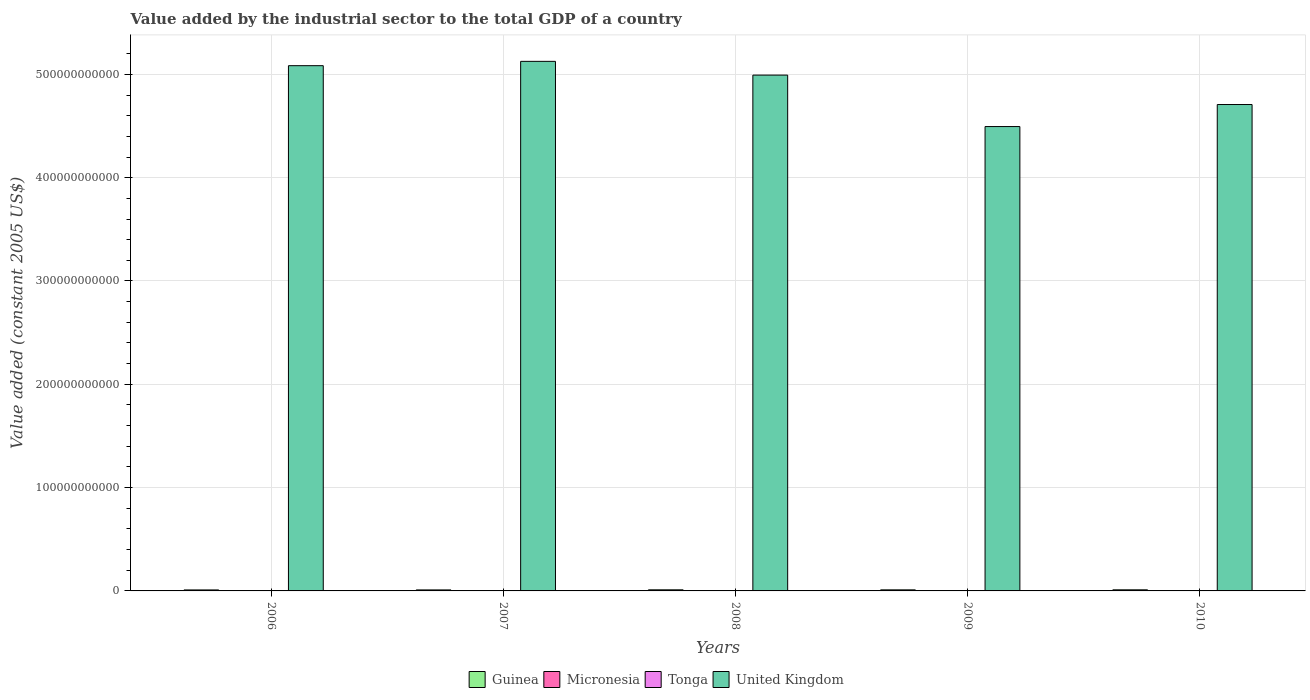How many groups of bars are there?
Your answer should be compact. 5. Are the number of bars per tick equal to the number of legend labels?
Make the answer very short. Yes. In how many cases, is the number of bars for a given year not equal to the number of legend labels?
Ensure brevity in your answer.  0. What is the value added by the industrial sector in Guinea in 2007?
Provide a short and direct response. 9.79e+08. Across all years, what is the maximum value added by the industrial sector in Guinea?
Make the answer very short. 1.07e+09. Across all years, what is the minimum value added by the industrial sector in United Kingdom?
Keep it short and to the point. 4.49e+11. What is the total value added by the industrial sector in Tonga in the graph?
Provide a short and direct response. 2.22e+08. What is the difference between the value added by the industrial sector in Micronesia in 2007 and that in 2008?
Give a very brief answer. -7.32e+05. What is the difference between the value added by the industrial sector in Micronesia in 2009 and the value added by the industrial sector in Tonga in 2006?
Make the answer very short. -2.85e+07. What is the average value added by the industrial sector in Micronesia per year?
Provide a short and direct response. 1.21e+07. In the year 2006, what is the difference between the value added by the industrial sector in United Kingdom and value added by the industrial sector in Tonga?
Offer a terse response. 5.08e+11. What is the ratio of the value added by the industrial sector in Micronesia in 2006 to that in 2008?
Offer a very short reply. 0.99. What is the difference between the highest and the second highest value added by the industrial sector in Tonga?
Ensure brevity in your answer.  5.36e+06. What is the difference between the highest and the lowest value added by the industrial sector in United Kingdom?
Provide a succinct answer. 6.31e+1. In how many years, is the value added by the industrial sector in United Kingdom greater than the average value added by the industrial sector in United Kingdom taken over all years?
Ensure brevity in your answer.  3. Is the sum of the value added by the industrial sector in Micronesia in 2006 and 2010 greater than the maximum value added by the industrial sector in Guinea across all years?
Give a very brief answer. No. What does the 3rd bar from the left in 2010 represents?
Offer a very short reply. Tonga. What does the 4th bar from the right in 2008 represents?
Give a very brief answer. Guinea. How many bars are there?
Offer a very short reply. 20. What is the difference between two consecutive major ticks on the Y-axis?
Your answer should be compact. 1.00e+11. Where does the legend appear in the graph?
Give a very brief answer. Bottom center. How many legend labels are there?
Your answer should be compact. 4. What is the title of the graph?
Provide a succinct answer. Value added by the industrial sector to the total GDP of a country. Does "New Caledonia" appear as one of the legend labels in the graph?
Your answer should be compact. No. What is the label or title of the X-axis?
Provide a succinct answer. Years. What is the label or title of the Y-axis?
Your answer should be very brief. Value added (constant 2005 US$). What is the Value added (constant 2005 US$) in Guinea in 2006?
Make the answer very short. 9.63e+08. What is the Value added (constant 2005 US$) of Micronesia in 2006?
Your answer should be compact. 1.03e+07. What is the Value added (constant 2005 US$) in Tonga in 2006?
Give a very brief answer. 4.26e+07. What is the Value added (constant 2005 US$) of United Kingdom in 2006?
Offer a very short reply. 5.08e+11. What is the Value added (constant 2005 US$) of Guinea in 2007?
Offer a terse response. 9.79e+08. What is the Value added (constant 2005 US$) of Micronesia in 2007?
Offer a terse response. 9.61e+06. What is the Value added (constant 2005 US$) of Tonga in 2007?
Ensure brevity in your answer.  4.06e+07. What is the Value added (constant 2005 US$) of United Kingdom in 2007?
Your answer should be very brief. 5.13e+11. What is the Value added (constant 2005 US$) of Guinea in 2008?
Your answer should be compact. 1.07e+09. What is the Value added (constant 2005 US$) of Micronesia in 2008?
Make the answer very short. 1.03e+07. What is the Value added (constant 2005 US$) in Tonga in 2008?
Your answer should be very brief. 4.08e+07. What is the Value added (constant 2005 US$) of United Kingdom in 2008?
Your answer should be compact. 4.99e+11. What is the Value added (constant 2005 US$) of Guinea in 2009?
Give a very brief answer. 1.04e+09. What is the Value added (constant 2005 US$) in Micronesia in 2009?
Give a very brief answer. 1.41e+07. What is the Value added (constant 2005 US$) of Tonga in 2009?
Ensure brevity in your answer.  4.61e+07. What is the Value added (constant 2005 US$) in United Kingdom in 2009?
Offer a terse response. 4.49e+11. What is the Value added (constant 2005 US$) of Guinea in 2010?
Offer a terse response. 1.06e+09. What is the Value added (constant 2005 US$) in Micronesia in 2010?
Offer a terse response. 1.64e+07. What is the Value added (constant 2005 US$) of Tonga in 2010?
Give a very brief answer. 5.15e+07. What is the Value added (constant 2005 US$) of United Kingdom in 2010?
Your answer should be compact. 4.71e+11. Across all years, what is the maximum Value added (constant 2005 US$) of Guinea?
Offer a terse response. 1.07e+09. Across all years, what is the maximum Value added (constant 2005 US$) in Micronesia?
Keep it short and to the point. 1.64e+07. Across all years, what is the maximum Value added (constant 2005 US$) of Tonga?
Your answer should be compact. 5.15e+07. Across all years, what is the maximum Value added (constant 2005 US$) in United Kingdom?
Provide a succinct answer. 5.13e+11. Across all years, what is the minimum Value added (constant 2005 US$) of Guinea?
Your answer should be very brief. 9.63e+08. Across all years, what is the minimum Value added (constant 2005 US$) in Micronesia?
Your answer should be compact. 9.61e+06. Across all years, what is the minimum Value added (constant 2005 US$) in Tonga?
Ensure brevity in your answer.  4.06e+07. Across all years, what is the minimum Value added (constant 2005 US$) of United Kingdom?
Offer a terse response. 4.49e+11. What is the total Value added (constant 2005 US$) in Guinea in the graph?
Your answer should be very brief. 5.11e+09. What is the total Value added (constant 2005 US$) of Micronesia in the graph?
Your answer should be compact. 6.07e+07. What is the total Value added (constant 2005 US$) of Tonga in the graph?
Provide a succinct answer. 2.22e+08. What is the total Value added (constant 2005 US$) of United Kingdom in the graph?
Keep it short and to the point. 2.44e+12. What is the difference between the Value added (constant 2005 US$) in Guinea in 2006 and that in 2007?
Give a very brief answer. -1.61e+07. What is the difference between the Value added (constant 2005 US$) in Micronesia in 2006 and that in 2007?
Ensure brevity in your answer.  6.41e+05. What is the difference between the Value added (constant 2005 US$) in Tonga in 2006 and that in 2007?
Make the answer very short. 1.99e+06. What is the difference between the Value added (constant 2005 US$) in United Kingdom in 2006 and that in 2007?
Your answer should be very brief. -4.18e+09. What is the difference between the Value added (constant 2005 US$) in Guinea in 2006 and that in 2008?
Your answer should be compact. -1.08e+08. What is the difference between the Value added (constant 2005 US$) in Micronesia in 2006 and that in 2008?
Your answer should be very brief. -9.15e+04. What is the difference between the Value added (constant 2005 US$) in Tonga in 2006 and that in 2008?
Provide a short and direct response. 1.72e+06. What is the difference between the Value added (constant 2005 US$) of United Kingdom in 2006 and that in 2008?
Your answer should be very brief. 9.12e+09. What is the difference between the Value added (constant 2005 US$) in Guinea in 2006 and that in 2009?
Your answer should be compact. -7.47e+07. What is the difference between the Value added (constant 2005 US$) of Micronesia in 2006 and that in 2009?
Provide a succinct answer. -3.85e+06. What is the difference between the Value added (constant 2005 US$) in Tonga in 2006 and that in 2009?
Your answer should be very brief. -3.56e+06. What is the difference between the Value added (constant 2005 US$) of United Kingdom in 2006 and that in 2009?
Give a very brief answer. 5.89e+1. What is the difference between the Value added (constant 2005 US$) in Guinea in 2006 and that in 2010?
Your answer should be very brief. -9.88e+07. What is the difference between the Value added (constant 2005 US$) in Micronesia in 2006 and that in 2010?
Your answer should be compact. -6.13e+06. What is the difference between the Value added (constant 2005 US$) in Tonga in 2006 and that in 2010?
Your answer should be compact. -8.92e+06. What is the difference between the Value added (constant 2005 US$) in United Kingdom in 2006 and that in 2010?
Keep it short and to the point. 3.76e+1. What is the difference between the Value added (constant 2005 US$) in Guinea in 2007 and that in 2008?
Give a very brief answer. -9.22e+07. What is the difference between the Value added (constant 2005 US$) in Micronesia in 2007 and that in 2008?
Provide a short and direct response. -7.32e+05. What is the difference between the Value added (constant 2005 US$) of Tonga in 2007 and that in 2008?
Provide a short and direct response. -2.68e+05. What is the difference between the Value added (constant 2005 US$) of United Kingdom in 2007 and that in 2008?
Ensure brevity in your answer.  1.33e+1. What is the difference between the Value added (constant 2005 US$) in Guinea in 2007 and that in 2009?
Provide a succinct answer. -5.86e+07. What is the difference between the Value added (constant 2005 US$) in Micronesia in 2007 and that in 2009?
Offer a very short reply. -4.49e+06. What is the difference between the Value added (constant 2005 US$) of Tonga in 2007 and that in 2009?
Your response must be concise. -5.55e+06. What is the difference between the Value added (constant 2005 US$) of United Kingdom in 2007 and that in 2009?
Provide a short and direct response. 6.31e+1. What is the difference between the Value added (constant 2005 US$) of Guinea in 2007 and that in 2010?
Offer a terse response. -8.27e+07. What is the difference between the Value added (constant 2005 US$) of Micronesia in 2007 and that in 2010?
Give a very brief answer. -6.77e+06. What is the difference between the Value added (constant 2005 US$) of Tonga in 2007 and that in 2010?
Give a very brief answer. -1.09e+07. What is the difference between the Value added (constant 2005 US$) of United Kingdom in 2007 and that in 2010?
Give a very brief answer. 4.18e+1. What is the difference between the Value added (constant 2005 US$) in Guinea in 2008 and that in 2009?
Provide a short and direct response. 3.36e+07. What is the difference between the Value added (constant 2005 US$) of Micronesia in 2008 and that in 2009?
Offer a terse response. -3.75e+06. What is the difference between the Value added (constant 2005 US$) in Tonga in 2008 and that in 2009?
Give a very brief answer. -5.28e+06. What is the difference between the Value added (constant 2005 US$) of United Kingdom in 2008 and that in 2009?
Offer a terse response. 4.98e+1. What is the difference between the Value added (constant 2005 US$) of Guinea in 2008 and that in 2010?
Make the answer very short. 9.56e+06. What is the difference between the Value added (constant 2005 US$) in Micronesia in 2008 and that in 2010?
Your answer should be compact. -6.04e+06. What is the difference between the Value added (constant 2005 US$) in Tonga in 2008 and that in 2010?
Keep it short and to the point. -1.06e+07. What is the difference between the Value added (constant 2005 US$) of United Kingdom in 2008 and that in 2010?
Your answer should be very brief. 2.85e+1. What is the difference between the Value added (constant 2005 US$) of Guinea in 2009 and that in 2010?
Give a very brief answer. -2.41e+07. What is the difference between the Value added (constant 2005 US$) of Micronesia in 2009 and that in 2010?
Give a very brief answer. -2.29e+06. What is the difference between the Value added (constant 2005 US$) of Tonga in 2009 and that in 2010?
Offer a terse response. -5.36e+06. What is the difference between the Value added (constant 2005 US$) in United Kingdom in 2009 and that in 2010?
Offer a terse response. -2.13e+1. What is the difference between the Value added (constant 2005 US$) of Guinea in 2006 and the Value added (constant 2005 US$) of Micronesia in 2007?
Offer a very short reply. 9.53e+08. What is the difference between the Value added (constant 2005 US$) of Guinea in 2006 and the Value added (constant 2005 US$) of Tonga in 2007?
Provide a succinct answer. 9.22e+08. What is the difference between the Value added (constant 2005 US$) of Guinea in 2006 and the Value added (constant 2005 US$) of United Kingdom in 2007?
Provide a short and direct response. -5.12e+11. What is the difference between the Value added (constant 2005 US$) in Micronesia in 2006 and the Value added (constant 2005 US$) in Tonga in 2007?
Provide a short and direct response. -3.03e+07. What is the difference between the Value added (constant 2005 US$) of Micronesia in 2006 and the Value added (constant 2005 US$) of United Kingdom in 2007?
Provide a succinct answer. -5.13e+11. What is the difference between the Value added (constant 2005 US$) in Tonga in 2006 and the Value added (constant 2005 US$) in United Kingdom in 2007?
Make the answer very short. -5.13e+11. What is the difference between the Value added (constant 2005 US$) of Guinea in 2006 and the Value added (constant 2005 US$) of Micronesia in 2008?
Your response must be concise. 9.53e+08. What is the difference between the Value added (constant 2005 US$) of Guinea in 2006 and the Value added (constant 2005 US$) of Tonga in 2008?
Ensure brevity in your answer.  9.22e+08. What is the difference between the Value added (constant 2005 US$) in Guinea in 2006 and the Value added (constant 2005 US$) in United Kingdom in 2008?
Your answer should be very brief. -4.98e+11. What is the difference between the Value added (constant 2005 US$) in Micronesia in 2006 and the Value added (constant 2005 US$) in Tonga in 2008?
Your response must be concise. -3.06e+07. What is the difference between the Value added (constant 2005 US$) of Micronesia in 2006 and the Value added (constant 2005 US$) of United Kingdom in 2008?
Offer a terse response. -4.99e+11. What is the difference between the Value added (constant 2005 US$) of Tonga in 2006 and the Value added (constant 2005 US$) of United Kingdom in 2008?
Offer a terse response. -4.99e+11. What is the difference between the Value added (constant 2005 US$) of Guinea in 2006 and the Value added (constant 2005 US$) of Micronesia in 2009?
Give a very brief answer. 9.49e+08. What is the difference between the Value added (constant 2005 US$) of Guinea in 2006 and the Value added (constant 2005 US$) of Tonga in 2009?
Your answer should be very brief. 9.17e+08. What is the difference between the Value added (constant 2005 US$) of Guinea in 2006 and the Value added (constant 2005 US$) of United Kingdom in 2009?
Provide a short and direct response. -4.49e+11. What is the difference between the Value added (constant 2005 US$) in Micronesia in 2006 and the Value added (constant 2005 US$) in Tonga in 2009?
Give a very brief answer. -3.59e+07. What is the difference between the Value added (constant 2005 US$) in Micronesia in 2006 and the Value added (constant 2005 US$) in United Kingdom in 2009?
Keep it short and to the point. -4.49e+11. What is the difference between the Value added (constant 2005 US$) in Tonga in 2006 and the Value added (constant 2005 US$) in United Kingdom in 2009?
Provide a short and direct response. -4.49e+11. What is the difference between the Value added (constant 2005 US$) in Guinea in 2006 and the Value added (constant 2005 US$) in Micronesia in 2010?
Provide a succinct answer. 9.47e+08. What is the difference between the Value added (constant 2005 US$) of Guinea in 2006 and the Value added (constant 2005 US$) of Tonga in 2010?
Ensure brevity in your answer.  9.12e+08. What is the difference between the Value added (constant 2005 US$) of Guinea in 2006 and the Value added (constant 2005 US$) of United Kingdom in 2010?
Give a very brief answer. -4.70e+11. What is the difference between the Value added (constant 2005 US$) of Micronesia in 2006 and the Value added (constant 2005 US$) of Tonga in 2010?
Offer a terse response. -4.12e+07. What is the difference between the Value added (constant 2005 US$) in Micronesia in 2006 and the Value added (constant 2005 US$) in United Kingdom in 2010?
Your answer should be very brief. -4.71e+11. What is the difference between the Value added (constant 2005 US$) of Tonga in 2006 and the Value added (constant 2005 US$) of United Kingdom in 2010?
Provide a short and direct response. -4.71e+11. What is the difference between the Value added (constant 2005 US$) in Guinea in 2007 and the Value added (constant 2005 US$) in Micronesia in 2008?
Ensure brevity in your answer.  9.69e+08. What is the difference between the Value added (constant 2005 US$) of Guinea in 2007 and the Value added (constant 2005 US$) of Tonga in 2008?
Provide a short and direct response. 9.38e+08. What is the difference between the Value added (constant 2005 US$) in Guinea in 2007 and the Value added (constant 2005 US$) in United Kingdom in 2008?
Your answer should be very brief. -4.98e+11. What is the difference between the Value added (constant 2005 US$) of Micronesia in 2007 and the Value added (constant 2005 US$) of Tonga in 2008?
Provide a short and direct response. -3.12e+07. What is the difference between the Value added (constant 2005 US$) of Micronesia in 2007 and the Value added (constant 2005 US$) of United Kingdom in 2008?
Your answer should be compact. -4.99e+11. What is the difference between the Value added (constant 2005 US$) in Tonga in 2007 and the Value added (constant 2005 US$) in United Kingdom in 2008?
Offer a very short reply. -4.99e+11. What is the difference between the Value added (constant 2005 US$) in Guinea in 2007 and the Value added (constant 2005 US$) in Micronesia in 2009?
Offer a terse response. 9.65e+08. What is the difference between the Value added (constant 2005 US$) of Guinea in 2007 and the Value added (constant 2005 US$) of Tonga in 2009?
Offer a very short reply. 9.33e+08. What is the difference between the Value added (constant 2005 US$) of Guinea in 2007 and the Value added (constant 2005 US$) of United Kingdom in 2009?
Ensure brevity in your answer.  -4.49e+11. What is the difference between the Value added (constant 2005 US$) in Micronesia in 2007 and the Value added (constant 2005 US$) in Tonga in 2009?
Keep it short and to the point. -3.65e+07. What is the difference between the Value added (constant 2005 US$) of Micronesia in 2007 and the Value added (constant 2005 US$) of United Kingdom in 2009?
Ensure brevity in your answer.  -4.49e+11. What is the difference between the Value added (constant 2005 US$) in Tonga in 2007 and the Value added (constant 2005 US$) in United Kingdom in 2009?
Offer a terse response. -4.49e+11. What is the difference between the Value added (constant 2005 US$) in Guinea in 2007 and the Value added (constant 2005 US$) in Micronesia in 2010?
Your answer should be compact. 9.63e+08. What is the difference between the Value added (constant 2005 US$) of Guinea in 2007 and the Value added (constant 2005 US$) of Tonga in 2010?
Your answer should be compact. 9.28e+08. What is the difference between the Value added (constant 2005 US$) of Guinea in 2007 and the Value added (constant 2005 US$) of United Kingdom in 2010?
Ensure brevity in your answer.  -4.70e+11. What is the difference between the Value added (constant 2005 US$) of Micronesia in 2007 and the Value added (constant 2005 US$) of Tonga in 2010?
Provide a short and direct response. -4.19e+07. What is the difference between the Value added (constant 2005 US$) in Micronesia in 2007 and the Value added (constant 2005 US$) in United Kingdom in 2010?
Your answer should be compact. -4.71e+11. What is the difference between the Value added (constant 2005 US$) in Tonga in 2007 and the Value added (constant 2005 US$) in United Kingdom in 2010?
Your answer should be compact. -4.71e+11. What is the difference between the Value added (constant 2005 US$) of Guinea in 2008 and the Value added (constant 2005 US$) of Micronesia in 2009?
Make the answer very short. 1.06e+09. What is the difference between the Value added (constant 2005 US$) of Guinea in 2008 and the Value added (constant 2005 US$) of Tonga in 2009?
Offer a terse response. 1.03e+09. What is the difference between the Value added (constant 2005 US$) of Guinea in 2008 and the Value added (constant 2005 US$) of United Kingdom in 2009?
Provide a short and direct response. -4.48e+11. What is the difference between the Value added (constant 2005 US$) of Micronesia in 2008 and the Value added (constant 2005 US$) of Tonga in 2009?
Your answer should be very brief. -3.58e+07. What is the difference between the Value added (constant 2005 US$) in Micronesia in 2008 and the Value added (constant 2005 US$) in United Kingdom in 2009?
Provide a short and direct response. -4.49e+11. What is the difference between the Value added (constant 2005 US$) of Tonga in 2008 and the Value added (constant 2005 US$) of United Kingdom in 2009?
Your answer should be compact. -4.49e+11. What is the difference between the Value added (constant 2005 US$) in Guinea in 2008 and the Value added (constant 2005 US$) in Micronesia in 2010?
Your answer should be compact. 1.06e+09. What is the difference between the Value added (constant 2005 US$) of Guinea in 2008 and the Value added (constant 2005 US$) of Tonga in 2010?
Provide a short and direct response. 1.02e+09. What is the difference between the Value added (constant 2005 US$) of Guinea in 2008 and the Value added (constant 2005 US$) of United Kingdom in 2010?
Make the answer very short. -4.70e+11. What is the difference between the Value added (constant 2005 US$) in Micronesia in 2008 and the Value added (constant 2005 US$) in Tonga in 2010?
Keep it short and to the point. -4.11e+07. What is the difference between the Value added (constant 2005 US$) in Micronesia in 2008 and the Value added (constant 2005 US$) in United Kingdom in 2010?
Offer a very short reply. -4.71e+11. What is the difference between the Value added (constant 2005 US$) in Tonga in 2008 and the Value added (constant 2005 US$) in United Kingdom in 2010?
Offer a very short reply. -4.71e+11. What is the difference between the Value added (constant 2005 US$) in Guinea in 2009 and the Value added (constant 2005 US$) in Micronesia in 2010?
Your response must be concise. 1.02e+09. What is the difference between the Value added (constant 2005 US$) of Guinea in 2009 and the Value added (constant 2005 US$) of Tonga in 2010?
Provide a succinct answer. 9.86e+08. What is the difference between the Value added (constant 2005 US$) in Guinea in 2009 and the Value added (constant 2005 US$) in United Kingdom in 2010?
Your response must be concise. -4.70e+11. What is the difference between the Value added (constant 2005 US$) of Micronesia in 2009 and the Value added (constant 2005 US$) of Tonga in 2010?
Ensure brevity in your answer.  -3.74e+07. What is the difference between the Value added (constant 2005 US$) of Micronesia in 2009 and the Value added (constant 2005 US$) of United Kingdom in 2010?
Give a very brief answer. -4.71e+11. What is the difference between the Value added (constant 2005 US$) of Tonga in 2009 and the Value added (constant 2005 US$) of United Kingdom in 2010?
Your answer should be compact. -4.71e+11. What is the average Value added (constant 2005 US$) in Guinea per year?
Ensure brevity in your answer.  1.02e+09. What is the average Value added (constant 2005 US$) of Micronesia per year?
Make the answer very short. 1.21e+07. What is the average Value added (constant 2005 US$) of Tonga per year?
Offer a terse response. 4.43e+07. What is the average Value added (constant 2005 US$) in United Kingdom per year?
Your answer should be very brief. 4.88e+11. In the year 2006, what is the difference between the Value added (constant 2005 US$) in Guinea and Value added (constant 2005 US$) in Micronesia?
Your answer should be very brief. 9.53e+08. In the year 2006, what is the difference between the Value added (constant 2005 US$) in Guinea and Value added (constant 2005 US$) in Tonga?
Provide a short and direct response. 9.21e+08. In the year 2006, what is the difference between the Value added (constant 2005 US$) in Guinea and Value added (constant 2005 US$) in United Kingdom?
Ensure brevity in your answer.  -5.07e+11. In the year 2006, what is the difference between the Value added (constant 2005 US$) in Micronesia and Value added (constant 2005 US$) in Tonga?
Your answer should be compact. -3.23e+07. In the year 2006, what is the difference between the Value added (constant 2005 US$) in Micronesia and Value added (constant 2005 US$) in United Kingdom?
Your response must be concise. -5.08e+11. In the year 2006, what is the difference between the Value added (constant 2005 US$) of Tonga and Value added (constant 2005 US$) of United Kingdom?
Provide a succinct answer. -5.08e+11. In the year 2007, what is the difference between the Value added (constant 2005 US$) in Guinea and Value added (constant 2005 US$) in Micronesia?
Keep it short and to the point. 9.70e+08. In the year 2007, what is the difference between the Value added (constant 2005 US$) of Guinea and Value added (constant 2005 US$) of Tonga?
Offer a terse response. 9.39e+08. In the year 2007, what is the difference between the Value added (constant 2005 US$) of Guinea and Value added (constant 2005 US$) of United Kingdom?
Give a very brief answer. -5.12e+11. In the year 2007, what is the difference between the Value added (constant 2005 US$) in Micronesia and Value added (constant 2005 US$) in Tonga?
Ensure brevity in your answer.  -3.10e+07. In the year 2007, what is the difference between the Value added (constant 2005 US$) of Micronesia and Value added (constant 2005 US$) of United Kingdom?
Make the answer very short. -5.13e+11. In the year 2007, what is the difference between the Value added (constant 2005 US$) in Tonga and Value added (constant 2005 US$) in United Kingdom?
Give a very brief answer. -5.13e+11. In the year 2008, what is the difference between the Value added (constant 2005 US$) of Guinea and Value added (constant 2005 US$) of Micronesia?
Provide a succinct answer. 1.06e+09. In the year 2008, what is the difference between the Value added (constant 2005 US$) in Guinea and Value added (constant 2005 US$) in Tonga?
Provide a short and direct response. 1.03e+09. In the year 2008, what is the difference between the Value added (constant 2005 US$) in Guinea and Value added (constant 2005 US$) in United Kingdom?
Your response must be concise. -4.98e+11. In the year 2008, what is the difference between the Value added (constant 2005 US$) of Micronesia and Value added (constant 2005 US$) of Tonga?
Ensure brevity in your answer.  -3.05e+07. In the year 2008, what is the difference between the Value added (constant 2005 US$) of Micronesia and Value added (constant 2005 US$) of United Kingdom?
Keep it short and to the point. -4.99e+11. In the year 2008, what is the difference between the Value added (constant 2005 US$) in Tonga and Value added (constant 2005 US$) in United Kingdom?
Your response must be concise. -4.99e+11. In the year 2009, what is the difference between the Value added (constant 2005 US$) of Guinea and Value added (constant 2005 US$) of Micronesia?
Offer a terse response. 1.02e+09. In the year 2009, what is the difference between the Value added (constant 2005 US$) in Guinea and Value added (constant 2005 US$) in Tonga?
Make the answer very short. 9.92e+08. In the year 2009, what is the difference between the Value added (constant 2005 US$) in Guinea and Value added (constant 2005 US$) in United Kingdom?
Provide a succinct answer. -4.48e+11. In the year 2009, what is the difference between the Value added (constant 2005 US$) of Micronesia and Value added (constant 2005 US$) of Tonga?
Offer a very short reply. -3.20e+07. In the year 2009, what is the difference between the Value added (constant 2005 US$) of Micronesia and Value added (constant 2005 US$) of United Kingdom?
Your response must be concise. -4.49e+11. In the year 2009, what is the difference between the Value added (constant 2005 US$) of Tonga and Value added (constant 2005 US$) of United Kingdom?
Offer a very short reply. -4.49e+11. In the year 2010, what is the difference between the Value added (constant 2005 US$) in Guinea and Value added (constant 2005 US$) in Micronesia?
Your answer should be very brief. 1.05e+09. In the year 2010, what is the difference between the Value added (constant 2005 US$) of Guinea and Value added (constant 2005 US$) of Tonga?
Your answer should be very brief. 1.01e+09. In the year 2010, what is the difference between the Value added (constant 2005 US$) in Guinea and Value added (constant 2005 US$) in United Kingdom?
Keep it short and to the point. -4.70e+11. In the year 2010, what is the difference between the Value added (constant 2005 US$) of Micronesia and Value added (constant 2005 US$) of Tonga?
Make the answer very short. -3.51e+07. In the year 2010, what is the difference between the Value added (constant 2005 US$) of Micronesia and Value added (constant 2005 US$) of United Kingdom?
Your answer should be compact. -4.71e+11. In the year 2010, what is the difference between the Value added (constant 2005 US$) in Tonga and Value added (constant 2005 US$) in United Kingdom?
Provide a succinct answer. -4.71e+11. What is the ratio of the Value added (constant 2005 US$) of Guinea in 2006 to that in 2007?
Provide a succinct answer. 0.98. What is the ratio of the Value added (constant 2005 US$) in Micronesia in 2006 to that in 2007?
Ensure brevity in your answer.  1.07. What is the ratio of the Value added (constant 2005 US$) of Tonga in 2006 to that in 2007?
Offer a very short reply. 1.05. What is the ratio of the Value added (constant 2005 US$) in Guinea in 2006 to that in 2008?
Provide a short and direct response. 0.9. What is the ratio of the Value added (constant 2005 US$) in Tonga in 2006 to that in 2008?
Provide a short and direct response. 1.04. What is the ratio of the Value added (constant 2005 US$) of United Kingdom in 2006 to that in 2008?
Your answer should be compact. 1.02. What is the ratio of the Value added (constant 2005 US$) in Guinea in 2006 to that in 2009?
Offer a very short reply. 0.93. What is the ratio of the Value added (constant 2005 US$) of Micronesia in 2006 to that in 2009?
Provide a succinct answer. 0.73. What is the ratio of the Value added (constant 2005 US$) in Tonga in 2006 to that in 2009?
Offer a terse response. 0.92. What is the ratio of the Value added (constant 2005 US$) of United Kingdom in 2006 to that in 2009?
Your response must be concise. 1.13. What is the ratio of the Value added (constant 2005 US$) of Guinea in 2006 to that in 2010?
Offer a terse response. 0.91. What is the ratio of the Value added (constant 2005 US$) in Micronesia in 2006 to that in 2010?
Make the answer very short. 0.63. What is the ratio of the Value added (constant 2005 US$) in Tonga in 2006 to that in 2010?
Offer a very short reply. 0.83. What is the ratio of the Value added (constant 2005 US$) in United Kingdom in 2006 to that in 2010?
Provide a short and direct response. 1.08. What is the ratio of the Value added (constant 2005 US$) of Guinea in 2007 to that in 2008?
Provide a succinct answer. 0.91. What is the ratio of the Value added (constant 2005 US$) of Micronesia in 2007 to that in 2008?
Provide a succinct answer. 0.93. What is the ratio of the Value added (constant 2005 US$) in Tonga in 2007 to that in 2008?
Keep it short and to the point. 0.99. What is the ratio of the Value added (constant 2005 US$) of United Kingdom in 2007 to that in 2008?
Your answer should be compact. 1.03. What is the ratio of the Value added (constant 2005 US$) of Guinea in 2007 to that in 2009?
Keep it short and to the point. 0.94. What is the ratio of the Value added (constant 2005 US$) of Micronesia in 2007 to that in 2009?
Make the answer very short. 0.68. What is the ratio of the Value added (constant 2005 US$) of Tonga in 2007 to that in 2009?
Provide a succinct answer. 0.88. What is the ratio of the Value added (constant 2005 US$) of United Kingdom in 2007 to that in 2009?
Provide a short and direct response. 1.14. What is the ratio of the Value added (constant 2005 US$) in Guinea in 2007 to that in 2010?
Your answer should be very brief. 0.92. What is the ratio of the Value added (constant 2005 US$) of Micronesia in 2007 to that in 2010?
Your answer should be compact. 0.59. What is the ratio of the Value added (constant 2005 US$) in Tonga in 2007 to that in 2010?
Offer a very short reply. 0.79. What is the ratio of the Value added (constant 2005 US$) in United Kingdom in 2007 to that in 2010?
Provide a succinct answer. 1.09. What is the ratio of the Value added (constant 2005 US$) of Guinea in 2008 to that in 2009?
Provide a succinct answer. 1.03. What is the ratio of the Value added (constant 2005 US$) of Micronesia in 2008 to that in 2009?
Ensure brevity in your answer.  0.73. What is the ratio of the Value added (constant 2005 US$) of Tonga in 2008 to that in 2009?
Keep it short and to the point. 0.89. What is the ratio of the Value added (constant 2005 US$) in United Kingdom in 2008 to that in 2009?
Ensure brevity in your answer.  1.11. What is the ratio of the Value added (constant 2005 US$) of Micronesia in 2008 to that in 2010?
Provide a short and direct response. 0.63. What is the ratio of the Value added (constant 2005 US$) in Tonga in 2008 to that in 2010?
Your response must be concise. 0.79. What is the ratio of the Value added (constant 2005 US$) of United Kingdom in 2008 to that in 2010?
Provide a short and direct response. 1.06. What is the ratio of the Value added (constant 2005 US$) of Guinea in 2009 to that in 2010?
Make the answer very short. 0.98. What is the ratio of the Value added (constant 2005 US$) of Micronesia in 2009 to that in 2010?
Make the answer very short. 0.86. What is the ratio of the Value added (constant 2005 US$) in Tonga in 2009 to that in 2010?
Give a very brief answer. 0.9. What is the ratio of the Value added (constant 2005 US$) of United Kingdom in 2009 to that in 2010?
Your answer should be very brief. 0.95. What is the difference between the highest and the second highest Value added (constant 2005 US$) in Guinea?
Ensure brevity in your answer.  9.56e+06. What is the difference between the highest and the second highest Value added (constant 2005 US$) of Micronesia?
Your answer should be compact. 2.29e+06. What is the difference between the highest and the second highest Value added (constant 2005 US$) of Tonga?
Your answer should be very brief. 5.36e+06. What is the difference between the highest and the second highest Value added (constant 2005 US$) of United Kingdom?
Provide a short and direct response. 4.18e+09. What is the difference between the highest and the lowest Value added (constant 2005 US$) in Guinea?
Your answer should be compact. 1.08e+08. What is the difference between the highest and the lowest Value added (constant 2005 US$) of Micronesia?
Provide a short and direct response. 6.77e+06. What is the difference between the highest and the lowest Value added (constant 2005 US$) of Tonga?
Give a very brief answer. 1.09e+07. What is the difference between the highest and the lowest Value added (constant 2005 US$) of United Kingdom?
Give a very brief answer. 6.31e+1. 